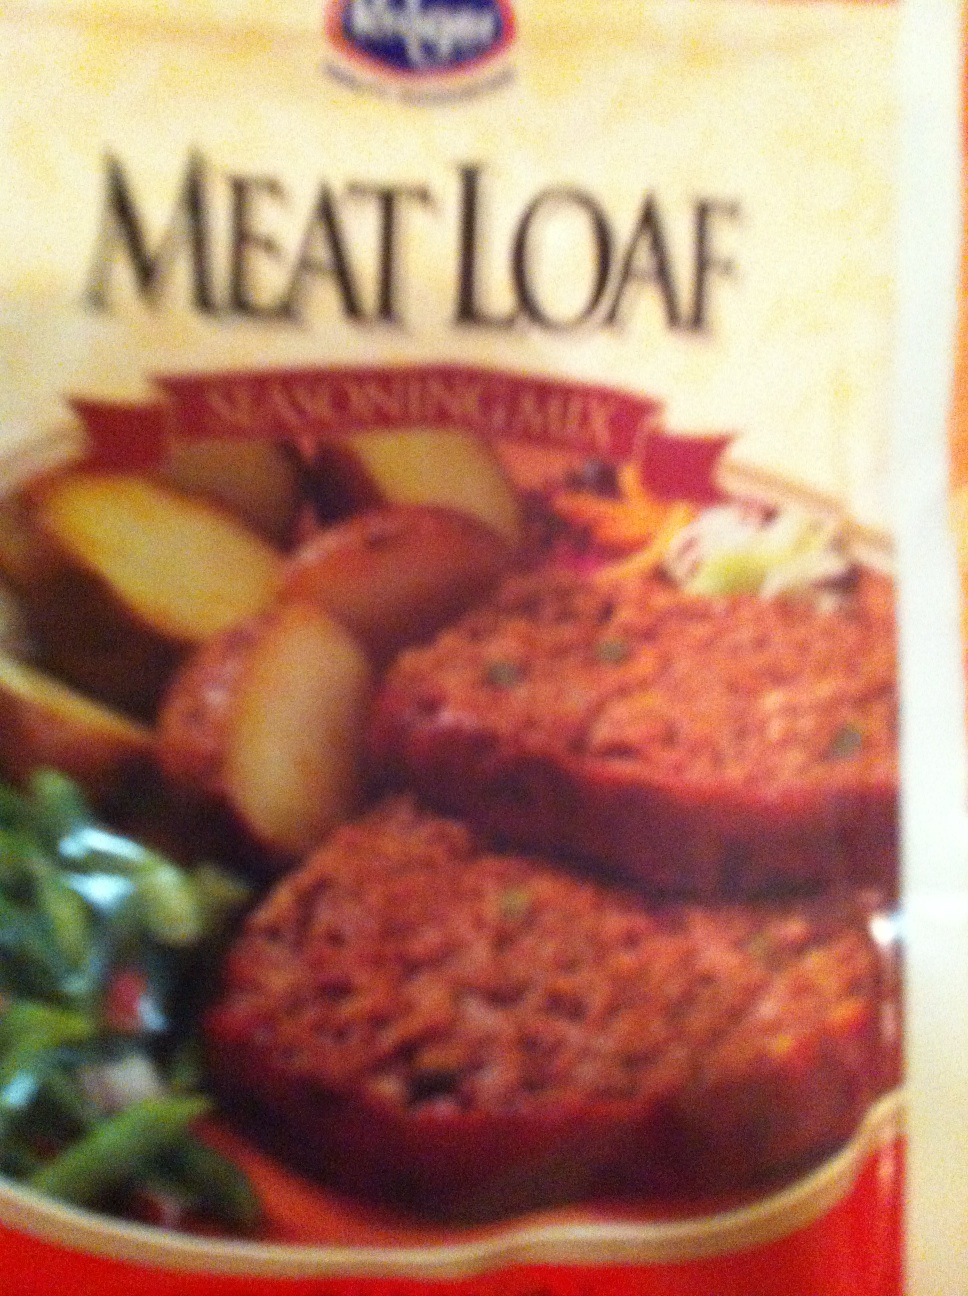Can you suggest some side dishes to serve with this meatloaf? Certainly! Classic side dishes that go well with meatloaf include mashed potatoes, steamed green beans, roasted vegetables, or a fresh garden salad. For a heartier meal, you might also consider adding macaroni and cheese or buttered corn. 